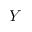Convert formula to latex. <formula><loc_0><loc_0><loc_500><loc_500>Y</formula> 